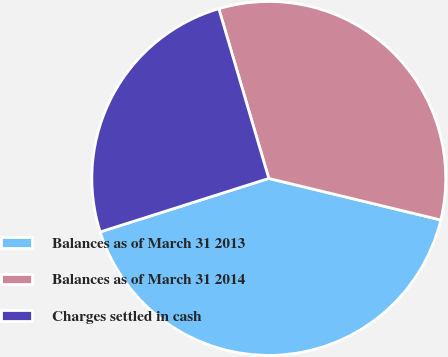<chart> <loc_0><loc_0><loc_500><loc_500><pie_chart><fcel>Balances as of March 31 2013<fcel>Balances as of March 31 2014<fcel>Charges settled in cash<nl><fcel>41.33%<fcel>33.33%<fcel>25.33%<nl></chart> 